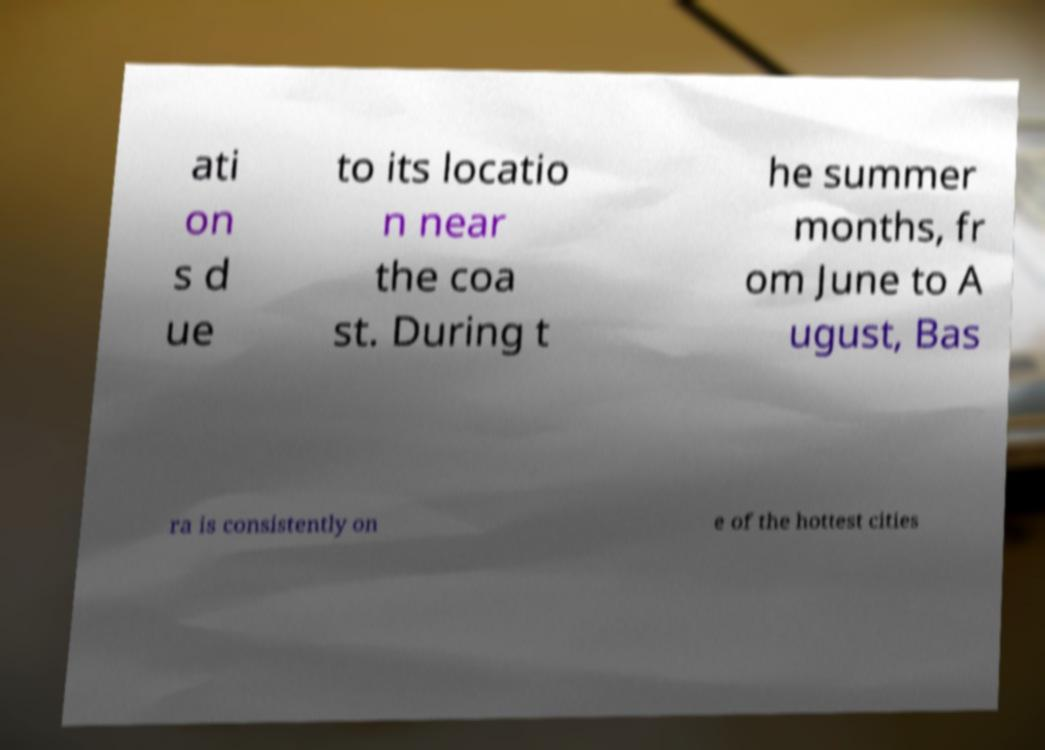What messages or text are displayed in this image? I need them in a readable, typed format. ati on s d ue to its locatio n near the coa st. During t he summer months, fr om June to A ugust, Bas ra is consistently on e of the hottest cities 